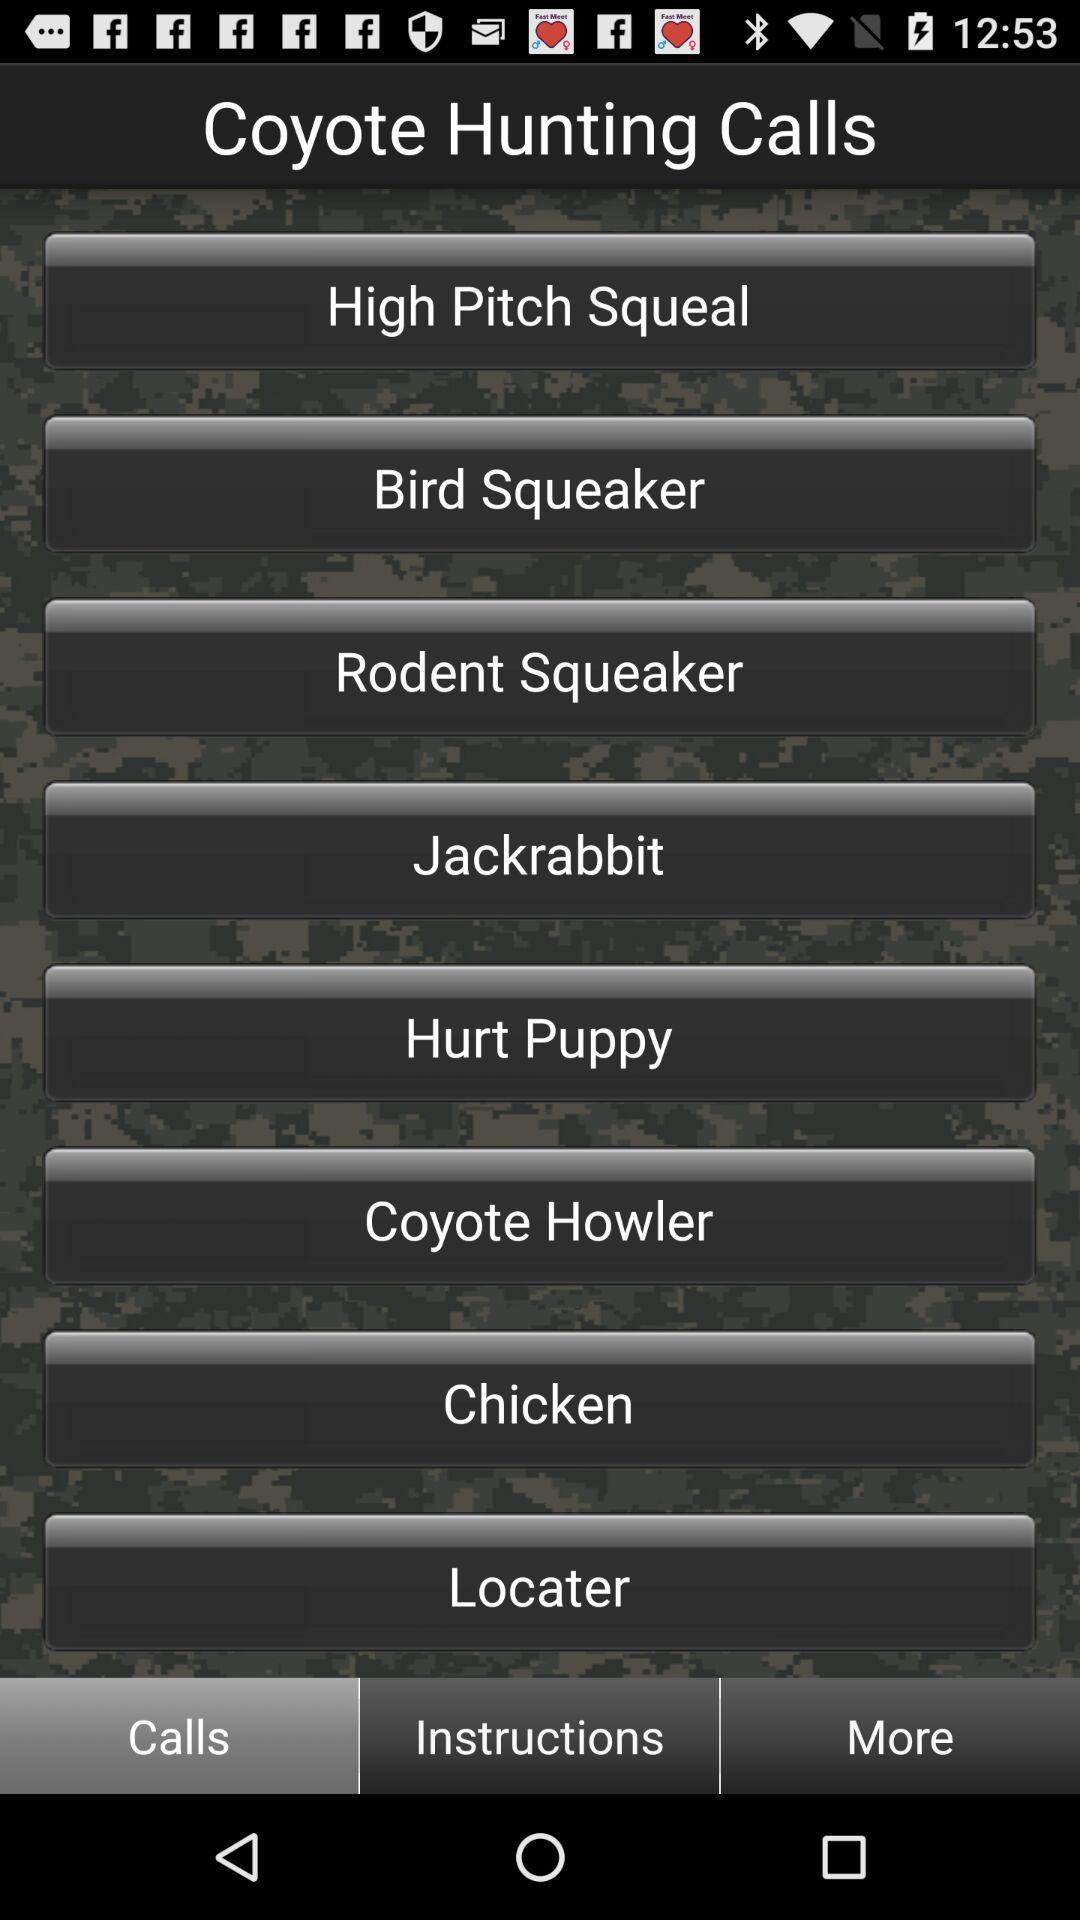Which tab is selected? The selected tab is "Calls". 